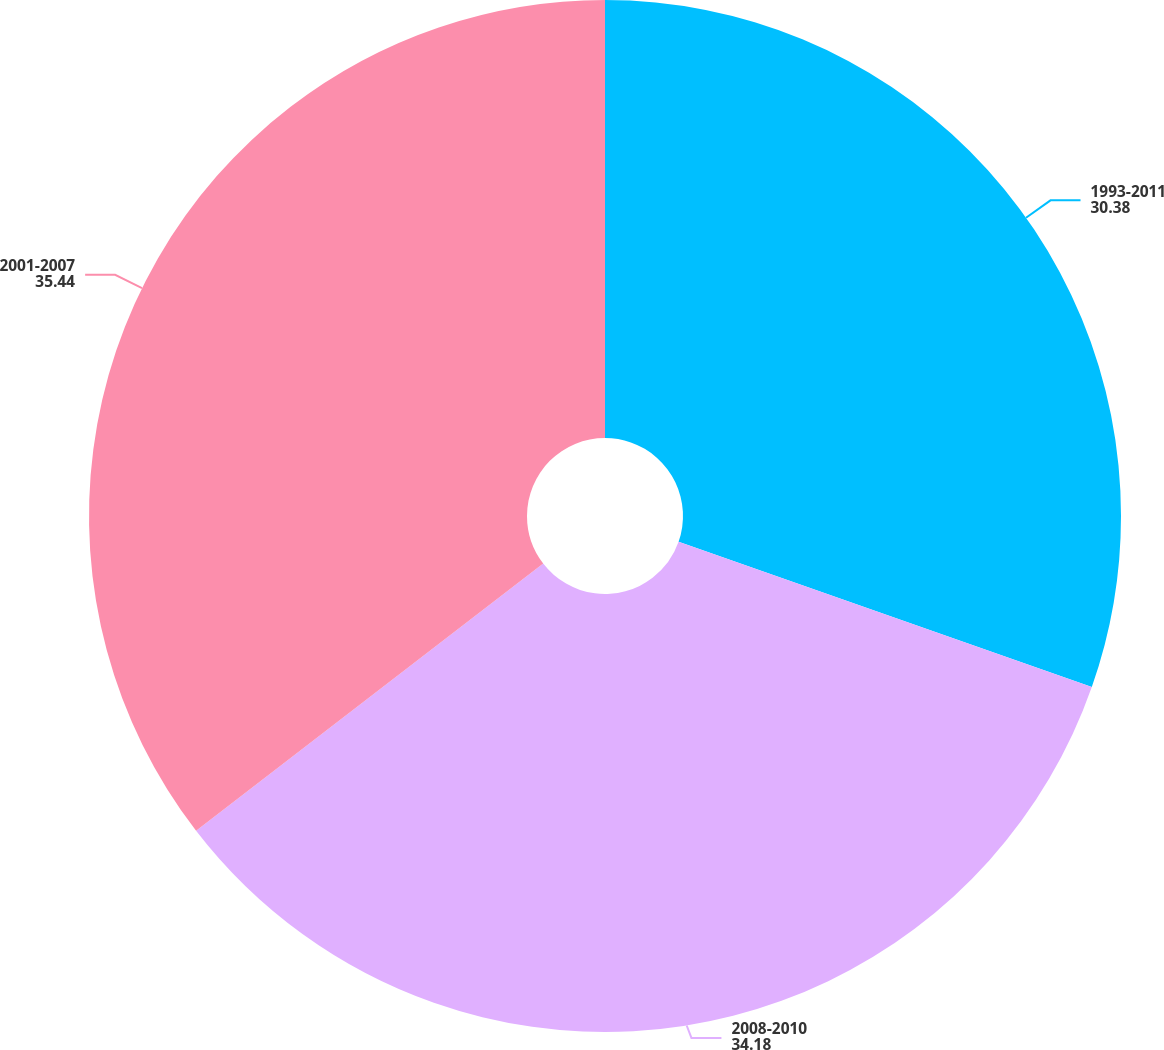Convert chart to OTSL. <chart><loc_0><loc_0><loc_500><loc_500><pie_chart><fcel>1993-2011<fcel>2008-2010<fcel>2001-2007<nl><fcel>30.38%<fcel>34.18%<fcel>35.44%<nl></chart> 